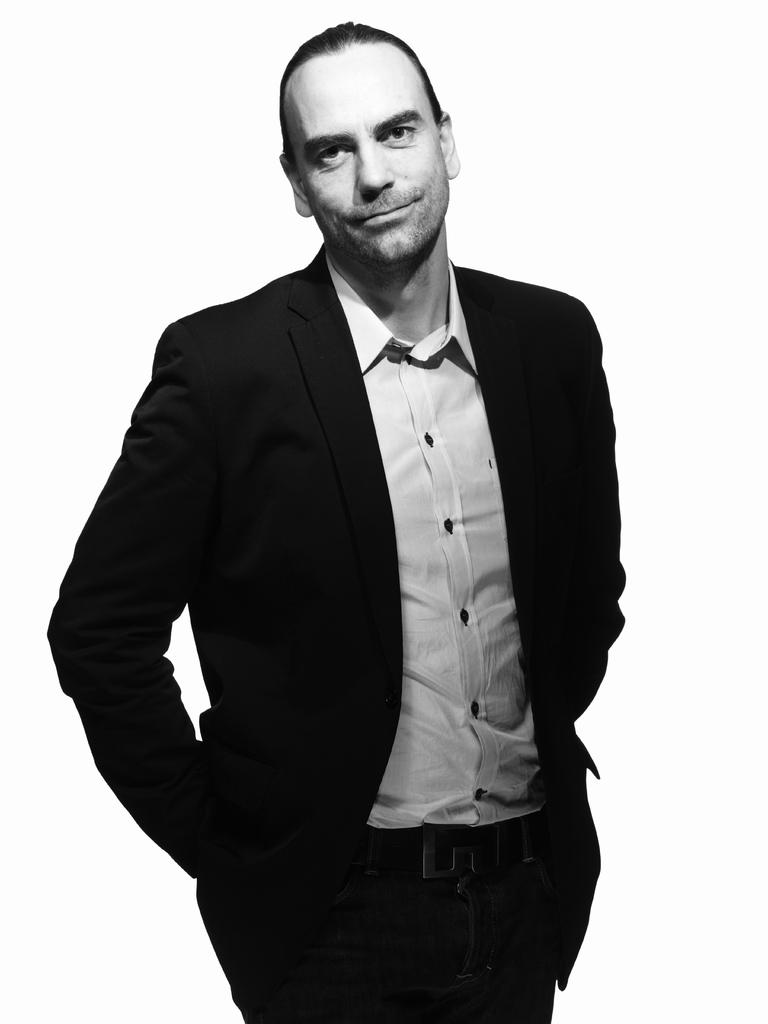Who is present in the image? There is a man in the image. What can be seen in the background of the image? The background of the image is white. What type of insect is crawling on the man's shoulder in the image? There is no insect present on the man's shoulder in the image. What type of doll is sitting next to the man in the image? There is no doll present in the image; only the man is visible. 